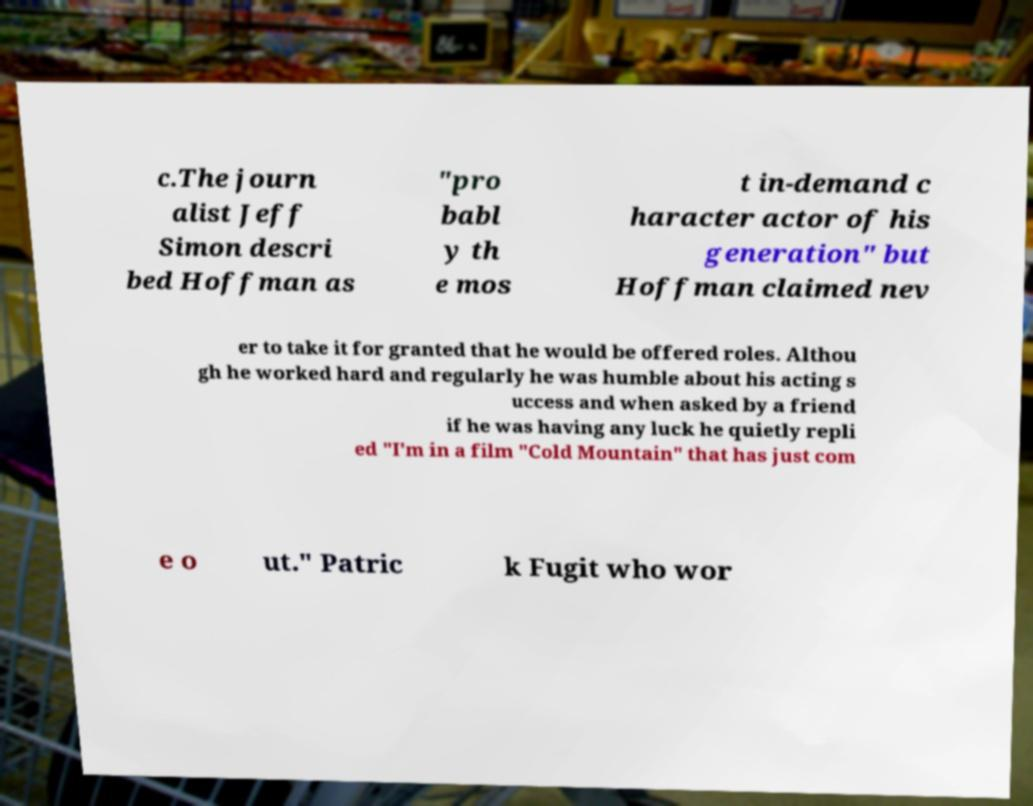Could you assist in decoding the text presented in this image and type it out clearly? c.The journ alist Jeff Simon descri bed Hoffman as "pro babl y th e mos t in-demand c haracter actor of his generation" but Hoffman claimed nev er to take it for granted that he would be offered roles. Althou gh he worked hard and regularly he was humble about his acting s uccess and when asked by a friend if he was having any luck he quietly repli ed "I'm in a film "Cold Mountain" that has just com e o ut." Patric k Fugit who wor 